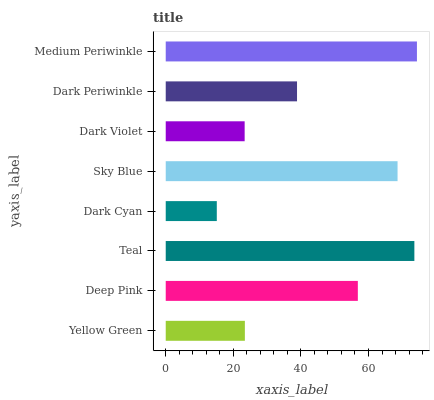Is Dark Cyan the minimum?
Answer yes or no. Yes. Is Medium Periwinkle the maximum?
Answer yes or no. Yes. Is Deep Pink the minimum?
Answer yes or no. No. Is Deep Pink the maximum?
Answer yes or no. No. Is Deep Pink greater than Yellow Green?
Answer yes or no. Yes. Is Yellow Green less than Deep Pink?
Answer yes or no. Yes. Is Yellow Green greater than Deep Pink?
Answer yes or no. No. Is Deep Pink less than Yellow Green?
Answer yes or no. No. Is Deep Pink the high median?
Answer yes or no. Yes. Is Dark Periwinkle the low median?
Answer yes or no. Yes. Is Medium Periwinkle the high median?
Answer yes or no. No. Is Yellow Green the low median?
Answer yes or no. No. 